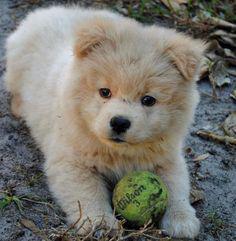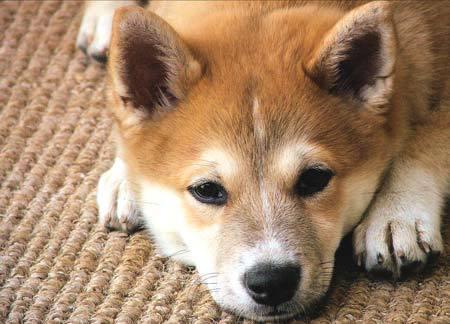The first image is the image on the left, the second image is the image on the right. For the images displayed, is the sentence "Some type of small toy is next to a fluffy dog in one image." factually correct? Answer yes or no. Yes. 